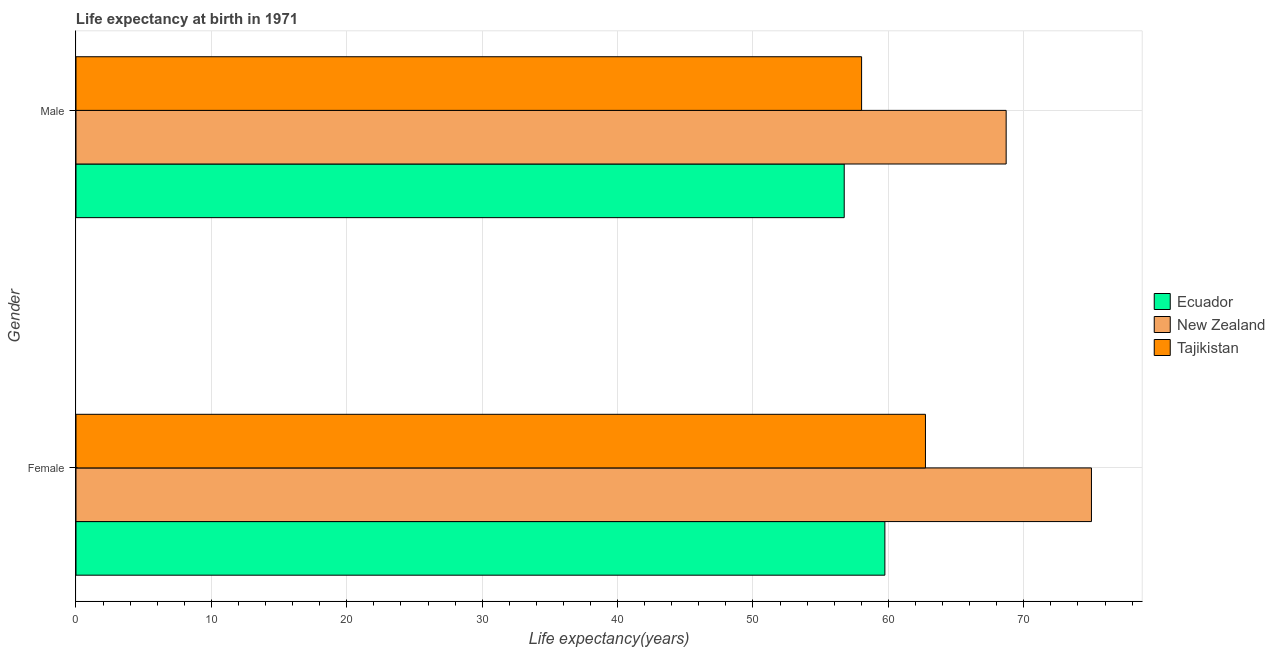How many different coloured bars are there?
Provide a succinct answer. 3. How many groups of bars are there?
Offer a terse response. 2. Are the number of bars per tick equal to the number of legend labels?
Your answer should be compact. Yes. Are the number of bars on each tick of the Y-axis equal?
Your answer should be very brief. Yes. How many bars are there on the 2nd tick from the top?
Provide a succinct answer. 3. What is the life expectancy(male) in Ecuador?
Offer a very short reply. 56.74. Across all countries, what is the maximum life expectancy(male)?
Your answer should be compact. 68.7. Across all countries, what is the minimum life expectancy(male)?
Offer a very short reply. 56.74. In which country was the life expectancy(female) maximum?
Keep it short and to the point. New Zealand. In which country was the life expectancy(male) minimum?
Your answer should be compact. Ecuador. What is the total life expectancy(female) in the graph?
Ensure brevity in your answer.  197.48. What is the difference between the life expectancy(male) in Ecuador and that in New Zealand?
Ensure brevity in your answer.  -11.96. What is the difference between the life expectancy(male) in Tajikistan and the life expectancy(female) in New Zealand?
Provide a short and direct response. -16.98. What is the average life expectancy(female) per country?
Your answer should be very brief. 65.83. What is the difference between the life expectancy(male) and life expectancy(female) in New Zealand?
Make the answer very short. -6.3. What is the ratio of the life expectancy(male) in Ecuador to that in New Zealand?
Keep it short and to the point. 0.83. Is the life expectancy(male) in Ecuador less than that in New Zealand?
Offer a very short reply. Yes. In how many countries, is the life expectancy(male) greater than the average life expectancy(male) taken over all countries?
Your answer should be compact. 1. What does the 1st bar from the top in Male represents?
Your response must be concise. Tajikistan. What does the 1st bar from the bottom in Male represents?
Your answer should be very brief. Ecuador. Are all the bars in the graph horizontal?
Offer a terse response. Yes. What is the difference between two consecutive major ticks on the X-axis?
Ensure brevity in your answer.  10. Are the values on the major ticks of X-axis written in scientific E-notation?
Your answer should be compact. No. Does the graph contain any zero values?
Ensure brevity in your answer.  No. Where does the legend appear in the graph?
Make the answer very short. Center right. How many legend labels are there?
Provide a succinct answer. 3. How are the legend labels stacked?
Provide a succinct answer. Vertical. What is the title of the graph?
Provide a short and direct response. Life expectancy at birth in 1971. What is the label or title of the X-axis?
Provide a succinct answer. Life expectancy(years). What is the Life expectancy(years) in Ecuador in Female?
Offer a very short reply. 59.74. What is the Life expectancy(years) in Tajikistan in Female?
Offer a terse response. 62.74. What is the Life expectancy(years) in Ecuador in Male?
Offer a terse response. 56.74. What is the Life expectancy(years) in New Zealand in Male?
Ensure brevity in your answer.  68.7. What is the Life expectancy(years) in Tajikistan in Male?
Your answer should be very brief. 58.02. Across all Gender, what is the maximum Life expectancy(years) of Ecuador?
Offer a very short reply. 59.74. Across all Gender, what is the maximum Life expectancy(years) of New Zealand?
Your answer should be very brief. 75. Across all Gender, what is the maximum Life expectancy(years) in Tajikistan?
Your answer should be very brief. 62.74. Across all Gender, what is the minimum Life expectancy(years) in Ecuador?
Provide a short and direct response. 56.74. Across all Gender, what is the minimum Life expectancy(years) of New Zealand?
Your answer should be very brief. 68.7. Across all Gender, what is the minimum Life expectancy(years) in Tajikistan?
Your answer should be very brief. 58.02. What is the total Life expectancy(years) in Ecuador in the graph?
Your answer should be compact. 116.48. What is the total Life expectancy(years) in New Zealand in the graph?
Your answer should be compact. 143.7. What is the total Life expectancy(years) in Tajikistan in the graph?
Keep it short and to the point. 120.76. What is the difference between the Life expectancy(years) of Ecuador in Female and that in Male?
Offer a very short reply. 3. What is the difference between the Life expectancy(years) of Tajikistan in Female and that in Male?
Your answer should be very brief. 4.72. What is the difference between the Life expectancy(years) in Ecuador in Female and the Life expectancy(years) in New Zealand in Male?
Offer a very short reply. -8.96. What is the difference between the Life expectancy(years) in Ecuador in Female and the Life expectancy(years) in Tajikistan in Male?
Your answer should be very brief. 1.72. What is the difference between the Life expectancy(years) of New Zealand in Female and the Life expectancy(years) of Tajikistan in Male?
Make the answer very short. 16.98. What is the average Life expectancy(years) of Ecuador per Gender?
Your answer should be compact. 58.24. What is the average Life expectancy(years) of New Zealand per Gender?
Keep it short and to the point. 71.85. What is the average Life expectancy(years) of Tajikistan per Gender?
Ensure brevity in your answer.  60.38. What is the difference between the Life expectancy(years) in Ecuador and Life expectancy(years) in New Zealand in Female?
Give a very brief answer. -15.26. What is the difference between the Life expectancy(years) of Ecuador and Life expectancy(years) of Tajikistan in Female?
Provide a short and direct response. -3. What is the difference between the Life expectancy(years) in New Zealand and Life expectancy(years) in Tajikistan in Female?
Your answer should be compact. 12.26. What is the difference between the Life expectancy(years) of Ecuador and Life expectancy(years) of New Zealand in Male?
Provide a short and direct response. -11.96. What is the difference between the Life expectancy(years) in Ecuador and Life expectancy(years) in Tajikistan in Male?
Offer a terse response. -1.28. What is the difference between the Life expectancy(years) in New Zealand and Life expectancy(years) in Tajikistan in Male?
Keep it short and to the point. 10.68. What is the ratio of the Life expectancy(years) of Ecuador in Female to that in Male?
Provide a succinct answer. 1.05. What is the ratio of the Life expectancy(years) in New Zealand in Female to that in Male?
Your answer should be very brief. 1.09. What is the ratio of the Life expectancy(years) of Tajikistan in Female to that in Male?
Ensure brevity in your answer.  1.08. What is the difference between the highest and the second highest Life expectancy(years) in Ecuador?
Keep it short and to the point. 3. What is the difference between the highest and the second highest Life expectancy(years) in New Zealand?
Your response must be concise. 6.3. What is the difference between the highest and the second highest Life expectancy(years) in Tajikistan?
Offer a terse response. 4.72. What is the difference between the highest and the lowest Life expectancy(years) of Ecuador?
Make the answer very short. 3. What is the difference between the highest and the lowest Life expectancy(years) in New Zealand?
Make the answer very short. 6.3. What is the difference between the highest and the lowest Life expectancy(years) of Tajikistan?
Provide a short and direct response. 4.72. 